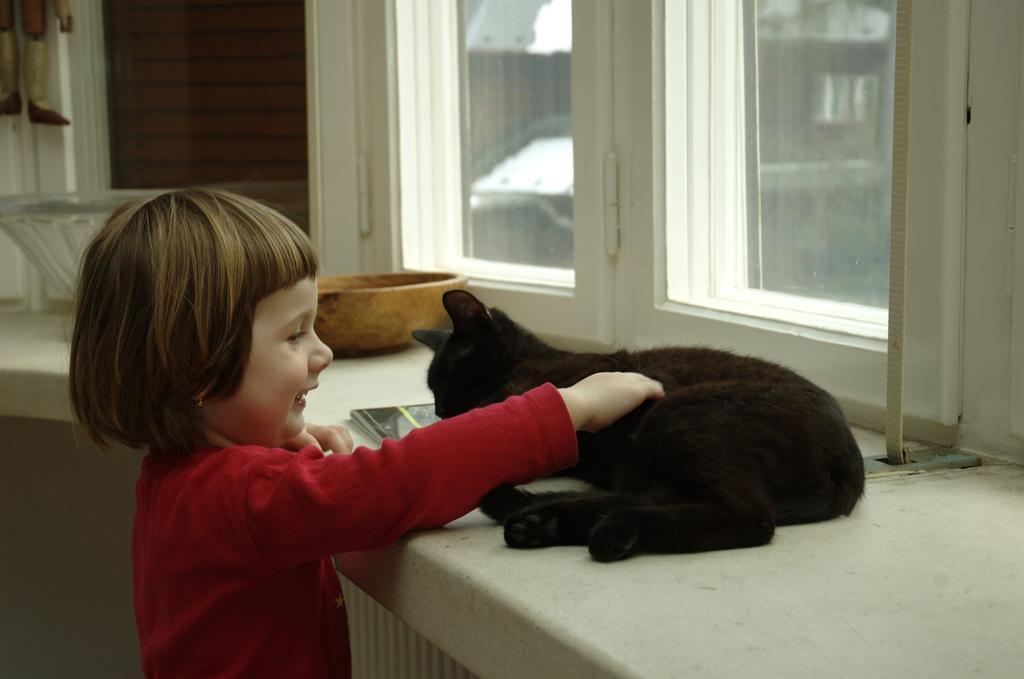Can you describe this image briefly? In this picture we can see girl standing and smiling and holding cat with her hands and aside to this cat we have books, bowl, window. 